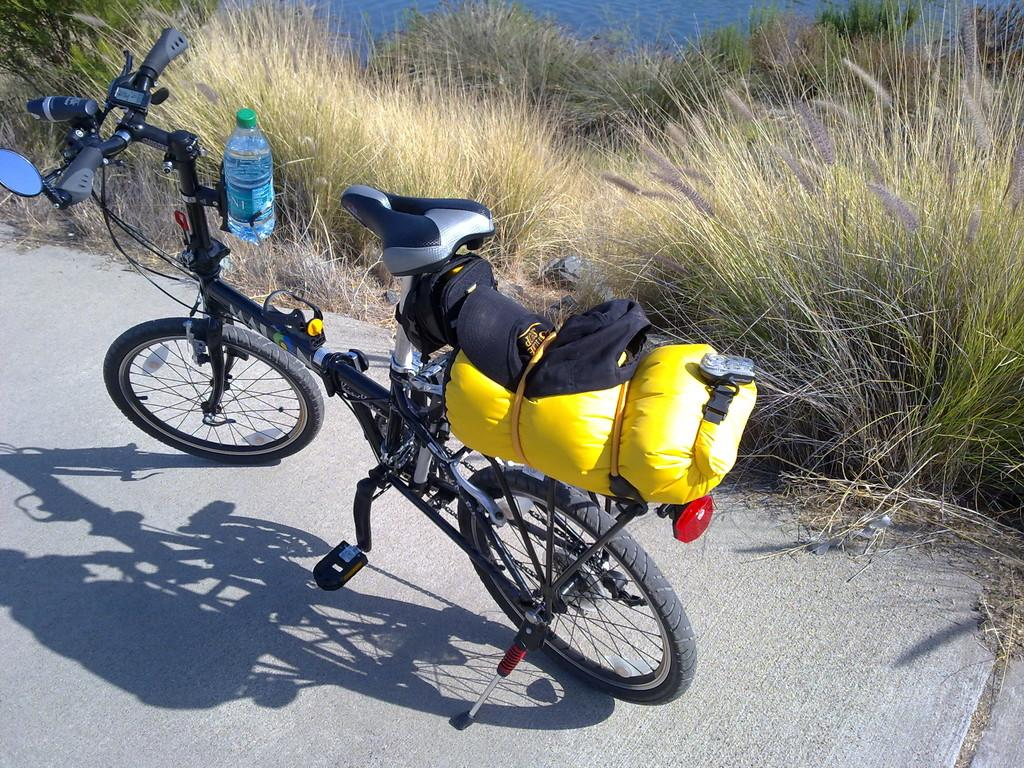What is the main object on the road in the image? There is a bicycle on the road in the image. What other object can be seen in the image? There is a bottle in the image. What is the cap associated with in the image? There is a cap in the image. What type of vegetation is near the bicycle in the image? There are plants beside the bicycle in the image. What type of sail can be seen on the bicycle in the image? There is no sail present on the bicycle in the image. How does the beginner learn to ride the bicycle in the image? The image does not provide information about the person riding the bicycle or their level of experience. 